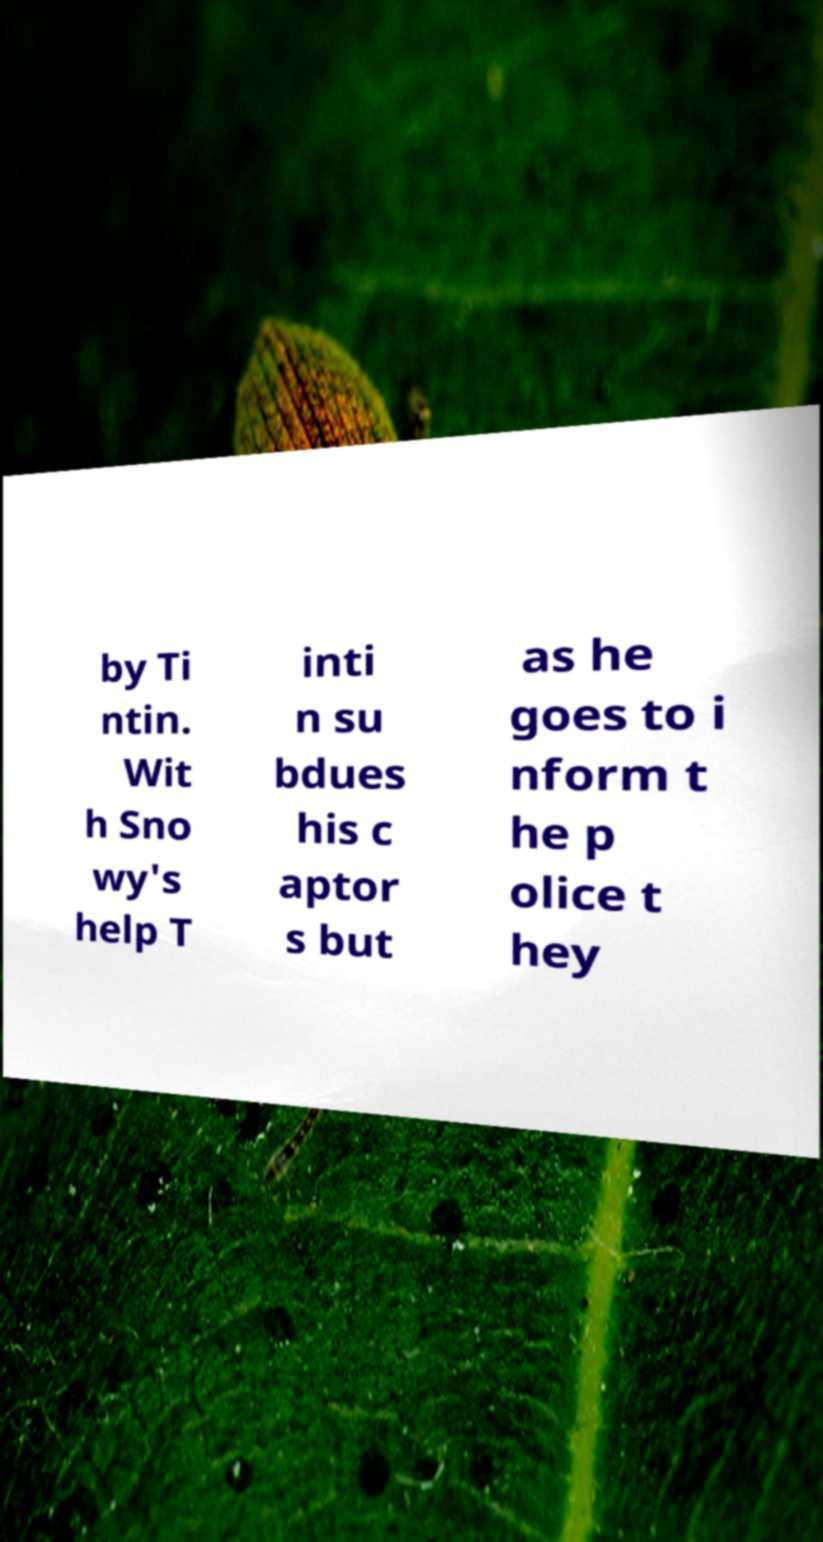What messages or text are displayed in this image? I need them in a readable, typed format. by Ti ntin. Wit h Sno wy's help T inti n su bdues his c aptor s but as he goes to i nform t he p olice t hey 